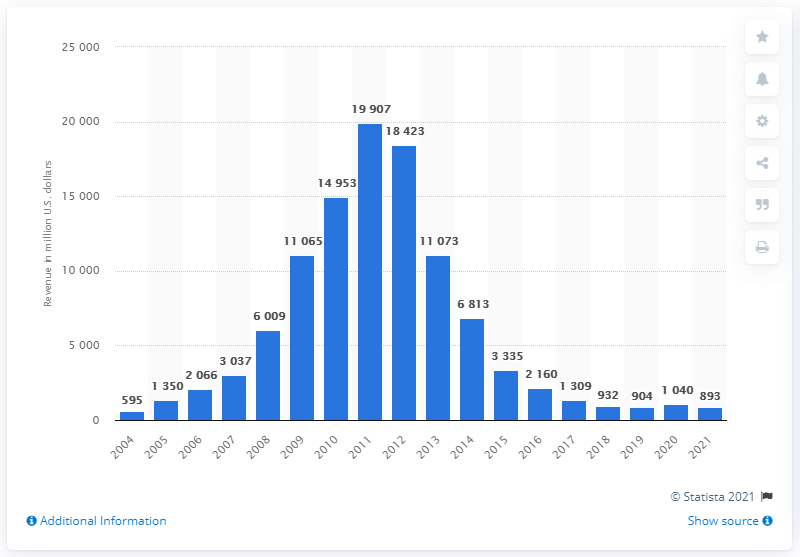Give some essential details in this illustration. In the year 2021, BlackBerry recorded revenues of 893 million U.S. dollars. In 2021, BlackBerry's revenue in the United States was approximately 893. 